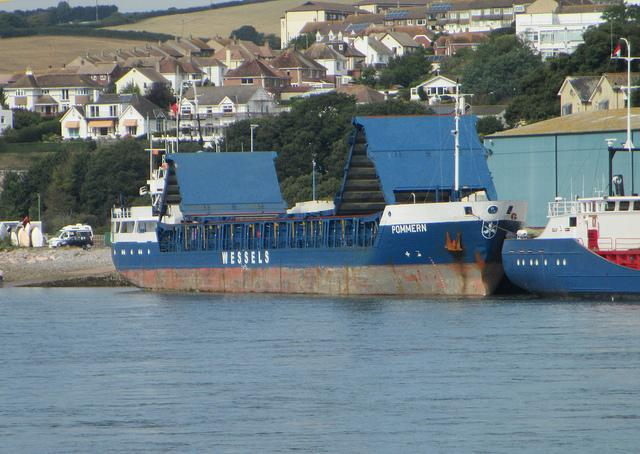The place where these ships are docked is known as? pier 